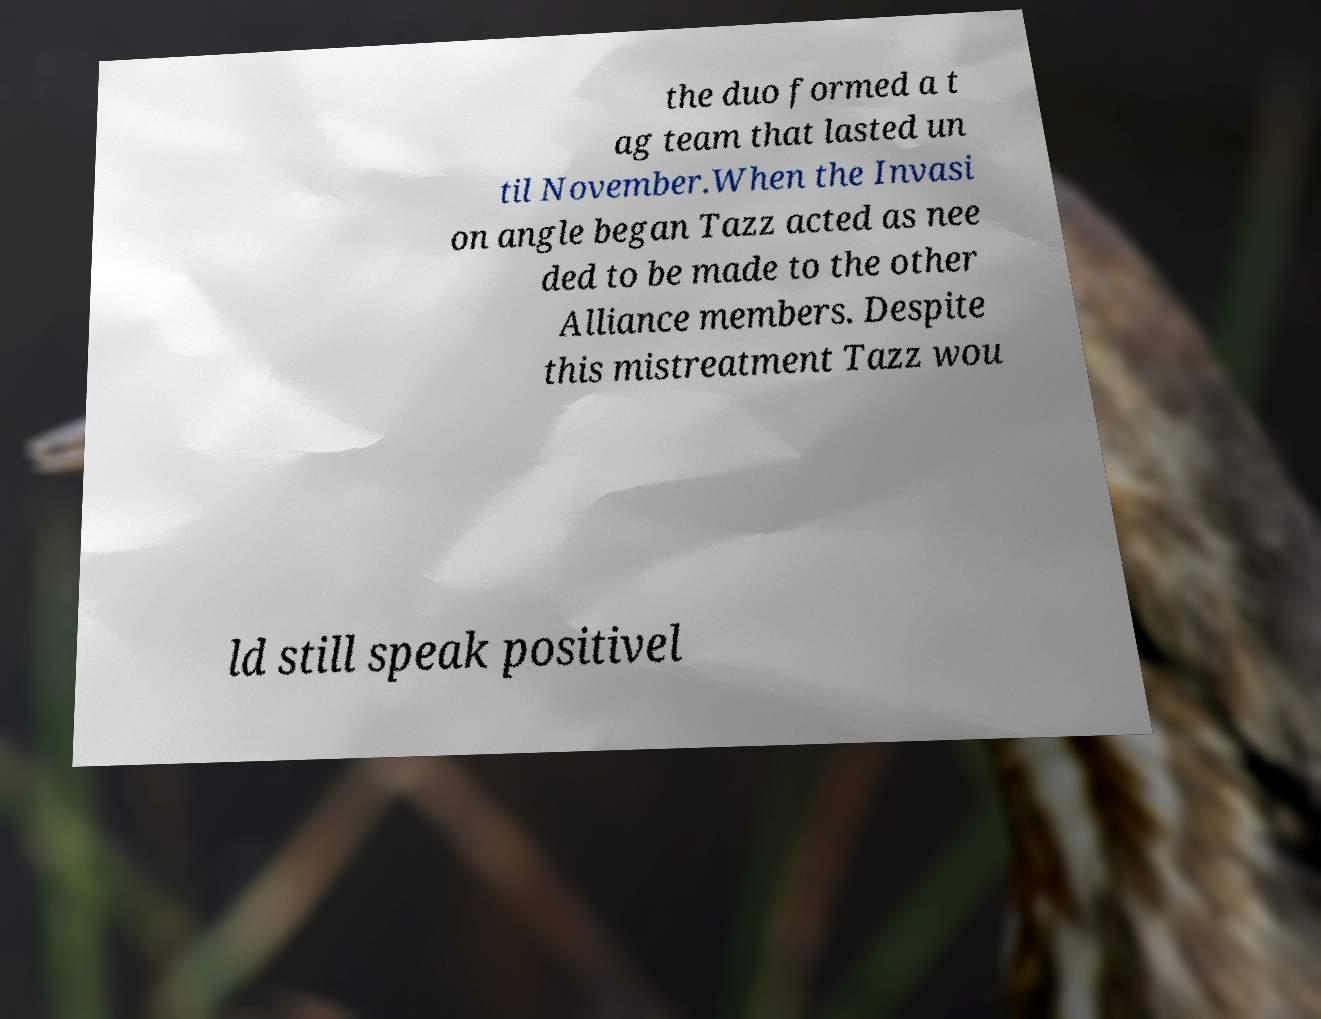Could you assist in decoding the text presented in this image and type it out clearly? the duo formed a t ag team that lasted un til November.When the Invasi on angle began Tazz acted as nee ded to be made to the other Alliance members. Despite this mistreatment Tazz wou ld still speak positivel 